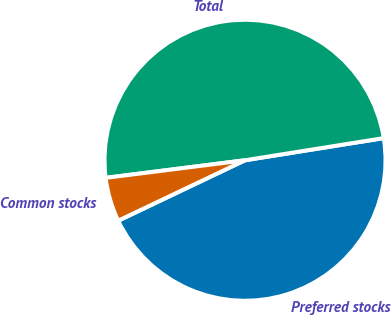<chart> <loc_0><loc_0><loc_500><loc_500><pie_chart><fcel>Preferred stocks<fcel>Total<fcel>Common stocks<nl><fcel>45.44%<fcel>49.48%<fcel>5.08%<nl></chart> 